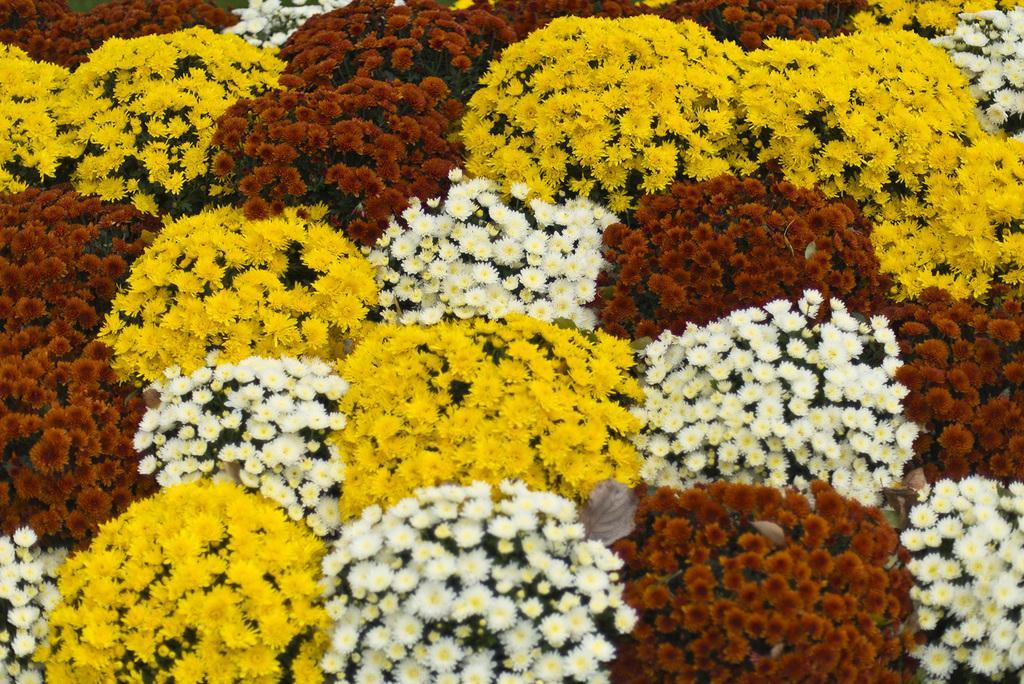In one or two sentences, can you explain what this image depicts? In the image there are many sunflowers of yellow,white and red color all over the place. 